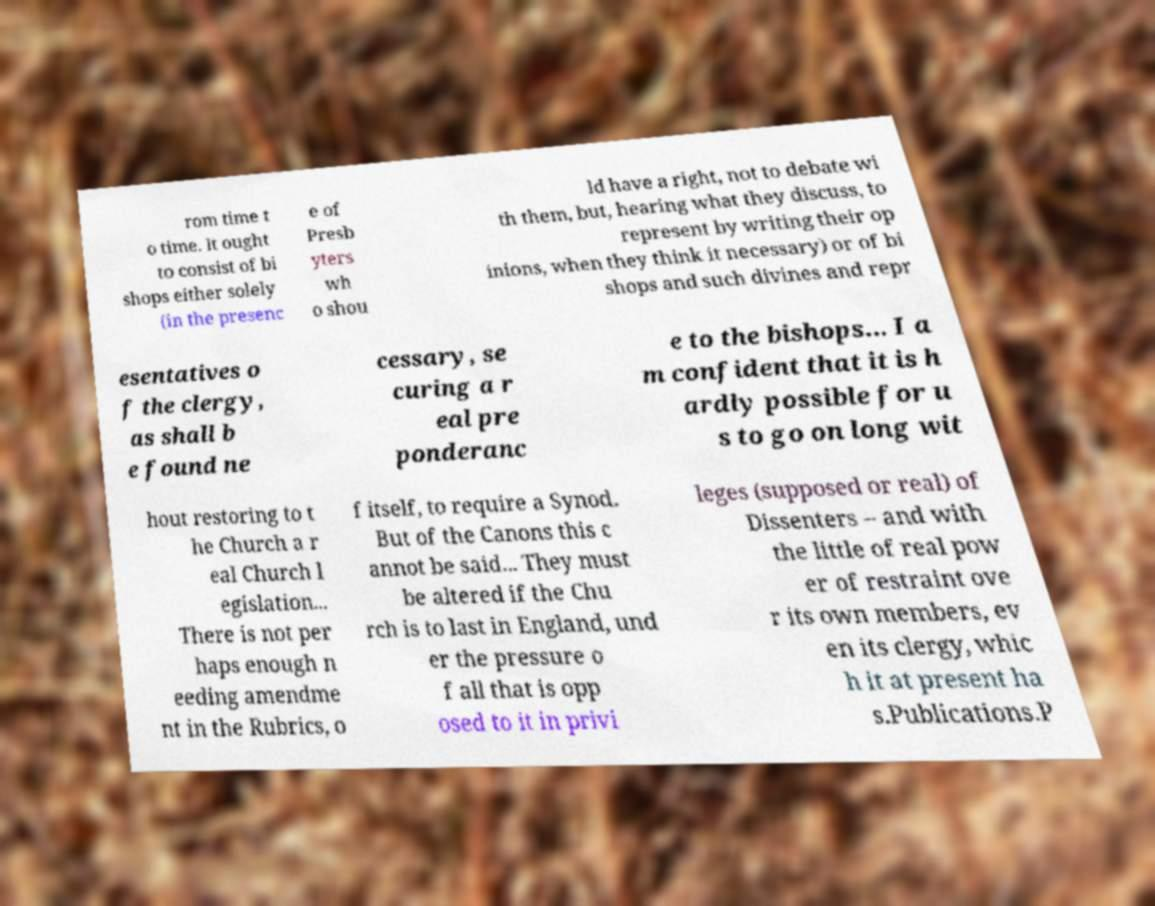Can you read and provide the text displayed in the image?This photo seems to have some interesting text. Can you extract and type it out for me? rom time t o time. It ought to consist of bi shops either solely (in the presenc e of Presb yters wh o shou ld have a right, not to debate wi th them, but, hearing what they discuss, to represent by writing their op inions, when they think it necessary) or of bi shops and such divines and repr esentatives o f the clergy, as shall b e found ne cessary, se curing a r eal pre ponderanc e to the bishops... I a m confident that it is h ardly possible for u s to go on long wit hout restoring to t he Church a r eal Church l egislation... There is not per haps enough n eeding amendme nt in the Rubrics, o f itself, to require a Synod. But of the Canons this c annot be said... They must be altered if the Chu rch is to last in England, und er the pressure o f all that is opp osed to it in privi leges (supposed or real) of Dissenters – and with the little of real pow er of restraint ove r its own members, ev en its clergy, whic h it at present ha s.Publications.P 